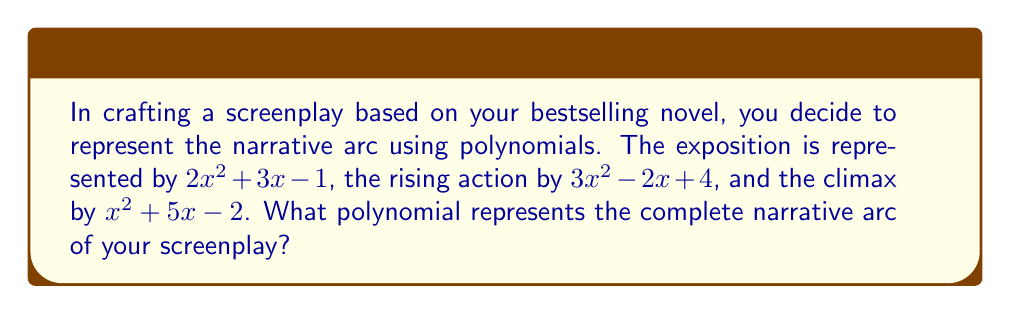Provide a solution to this math problem. To find the polynomial representing the complete narrative arc, we need to add the polynomials for each story element:

1. Exposition: $2x^2 + 3x - 1$
2. Rising action: $3x^2 - 2x + 4$
3. Climax: $x^2 + 5x - 2$

Let's add these polynomials term by term:

1. Combine the $x^2$ terms:
   $2x^2 + 3x^2 + x^2 = 6x^2$

2. Combine the $x$ terms:
   $3x + (-2x) + 5x = 6x$

3. Combine the constant terms:
   $-1 + 4 + (-2) = 1$

Now, we can write the resulting polynomial:

$$6x^2 + 6x + 1$$

This polynomial represents the complete narrative arc of your screenplay, combining the exposition, rising action, and climax.
Answer: $6x^2 + 6x + 1$ 